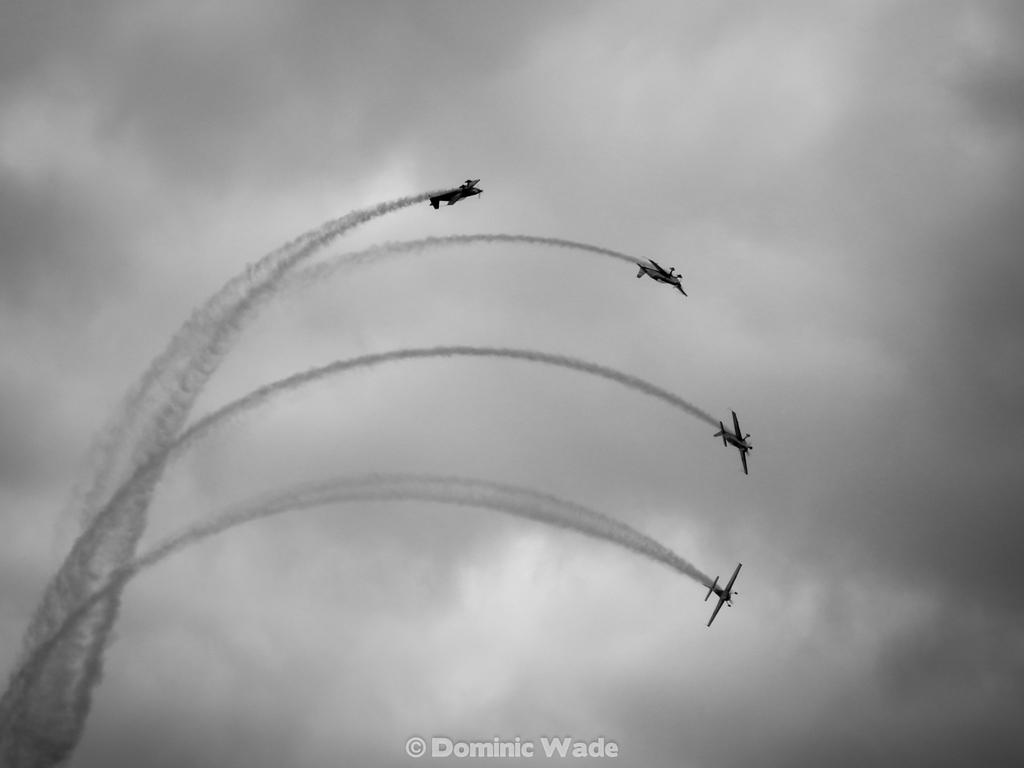What is the color scheme of the image? The image is black and white. What can be seen in the sky in the image? There are four jet planes flying in the sky. What type of natural formation is visible in the image? Clouds are visible in the image. Is there any additional information or branding on the image? Yes, there is a watermark on the image. How many visitors are present in the image? There are no visitors present in the image; it features four jet planes flying in the sky. What type of balance is being demonstrated by the objects in the image? There are no objects or subjects in the image that demonstrate balance; it features four jet planes flying in the sky. 